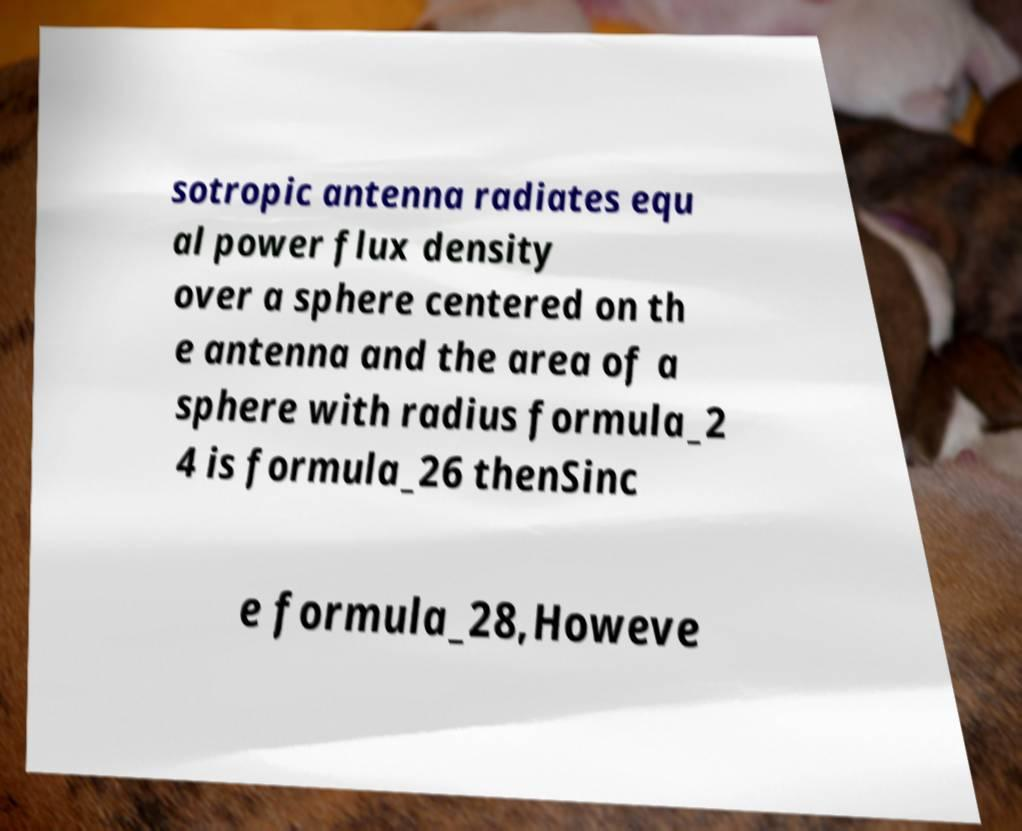What messages or text are displayed in this image? I need them in a readable, typed format. sotropic antenna radiates equ al power flux density over a sphere centered on th e antenna and the area of a sphere with radius formula_2 4 is formula_26 thenSinc e formula_28,Howeve 